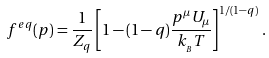<formula> <loc_0><loc_0><loc_500><loc_500>f ^ { e q } ( p ) = \frac { 1 } { Z _ { q } } \left [ 1 - ( 1 - q ) \frac { p ^ { \mu } U _ { \mu } } { k _ { _ { B } } T } \right ] ^ { 1 / ( 1 - q ) } \, .</formula> 